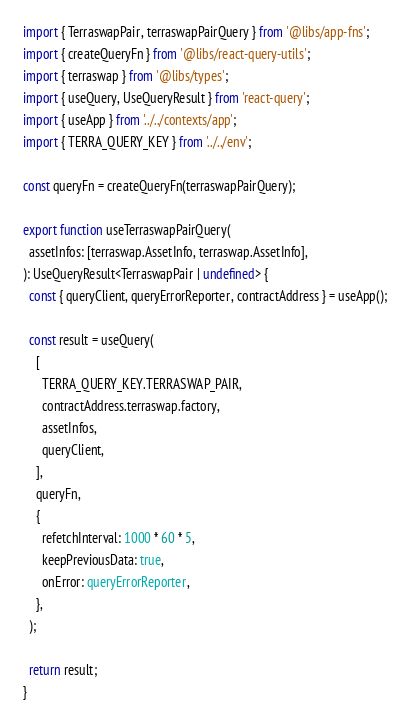<code> <loc_0><loc_0><loc_500><loc_500><_TypeScript_>import { TerraswapPair, terraswapPairQuery } from '@libs/app-fns';
import { createQueryFn } from '@libs/react-query-utils';
import { terraswap } from '@libs/types';
import { useQuery, UseQueryResult } from 'react-query';
import { useApp } from '../../contexts/app';
import { TERRA_QUERY_KEY } from '../../env';

const queryFn = createQueryFn(terraswapPairQuery);

export function useTerraswapPairQuery(
  assetInfos: [terraswap.AssetInfo, terraswap.AssetInfo],
): UseQueryResult<TerraswapPair | undefined> {
  const { queryClient, queryErrorReporter, contractAddress } = useApp();

  const result = useQuery(
    [
      TERRA_QUERY_KEY.TERRASWAP_PAIR,
      contractAddress.terraswap.factory,
      assetInfos,
      queryClient,
    ],
    queryFn,
    {
      refetchInterval: 1000 * 60 * 5,
      keepPreviousData: true,
      onError: queryErrorReporter,
    },
  );

  return result;
}
</code> 